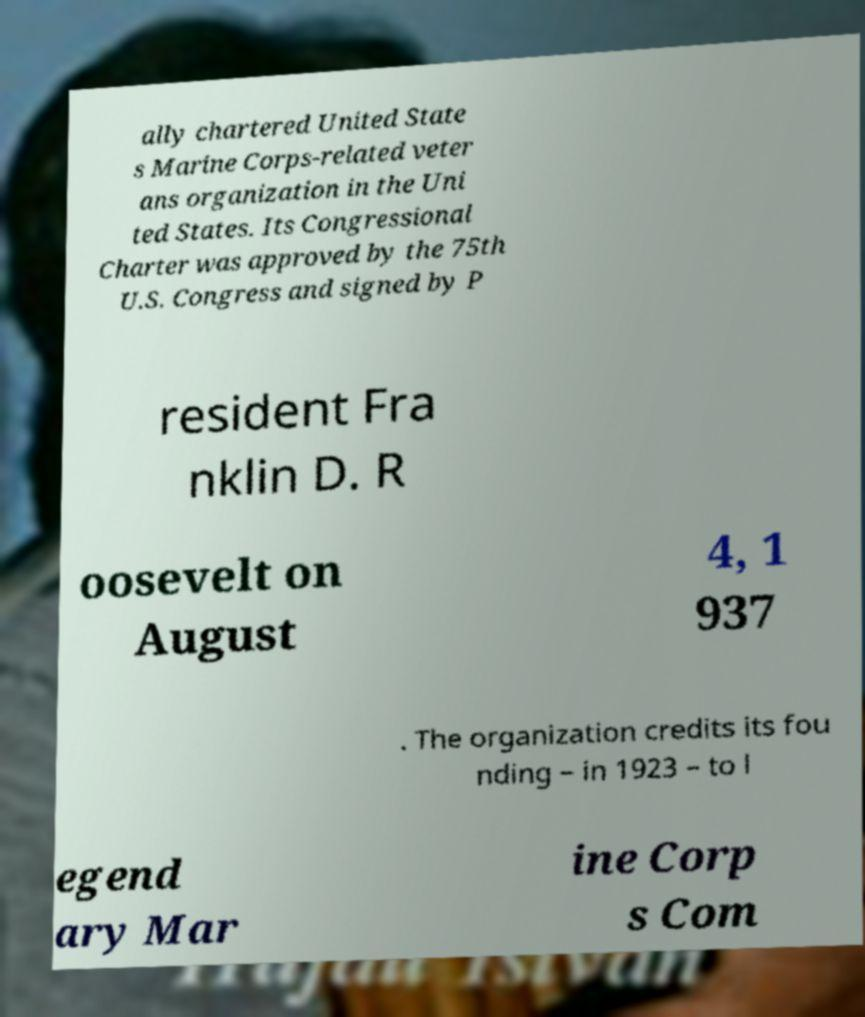Can you accurately transcribe the text from the provided image for me? ally chartered United State s Marine Corps-related veter ans organization in the Uni ted States. Its Congressional Charter was approved by the 75th U.S. Congress and signed by P resident Fra nklin D. R oosevelt on August 4, 1 937 . The organization credits its fou nding – in 1923 – to l egend ary Mar ine Corp s Com 